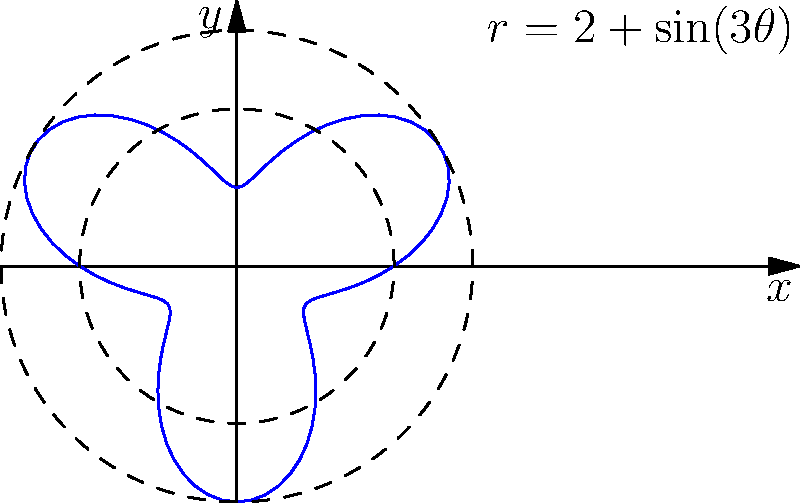In traditional Chinese medicine, the energy flow in a specific meridian is represented by the polar equation $r = 2 + \sin(3\theta)$. If the energy intensity is proportional to the radial distance from the origin, calculate the ratio of maximum to minimum energy intensity along this meridian. To find the ratio of maximum to minimum energy intensity, we need to determine the maximum and minimum radial distances:

1. The general form of the equation is $r = 2 + \sin(3\theta)$

2. Maximum r occurs when $\sin(3\theta) = 1$:
   $r_{max} = 2 + 1 = 3$

3. Minimum r occurs when $\sin(3\theta) = -1$:
   $r_{min} = 2 + (-1) = 1$

4. The ratio of maximum to minimum energy intensity is:
   $$\frac{r_{max}}{r_{min}} = \frac{3}{1} = 3$$

This ratio represents the variation in energy intensity along the meridian, with the maximum being three times the minimum.
Answer: 3 